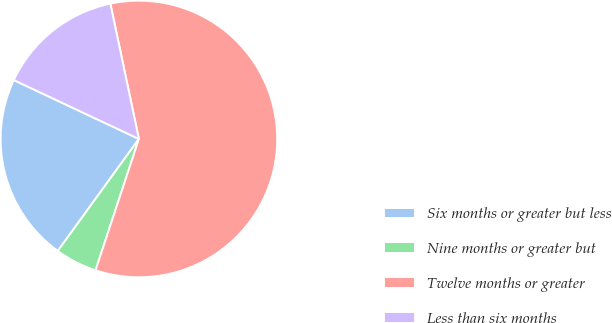Convert chart. <chart><loc_0><loc_0><loc_500><loc_500><pie_chart><fcel>Six months or greater but less<fcel>Nine months or greater but<fcel>Twelve months or greater<fcel>Less than six months<nl><fcel>22.03%<fcel>4.9%<fcel>58.39%<fcel>14.69%<nl></chart> 